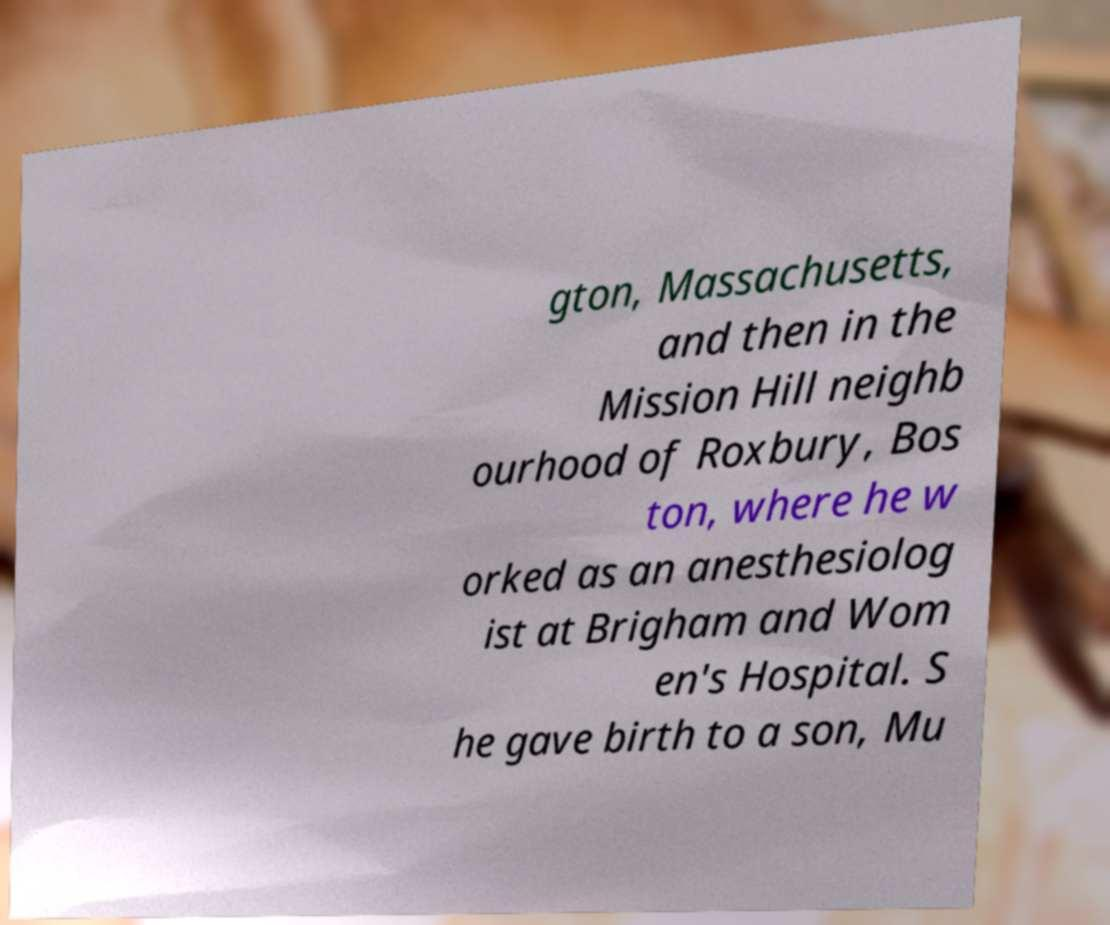Could you assist in decoding the text presented in this image and type it out clearly? gton, Massachusetts, and then in the Mission Hill neighb ourhood of Roxbury, Bos ton, where he w orked as an anesthesiolog ist at Brigham and Wom en's Hospital. S he gave birth to a son, Mu 